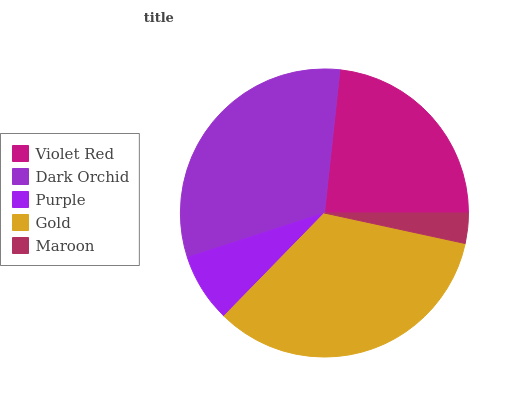Is Maroon the minimum?
Answer yes or no. Yes. Is Gold the maximum?
Answer yes or no. Yes. Is Dark Orchid the minimum?
Answer yes or no. No. Is Dark Orchid the maximum?
Answer yes or no. No. Is Dark Orchid greater than Violet Red?
Answer yes or no. Yes. Is Violet Red less than Dark Orchid?
Answer yes or no. Yes. Is Violet Red greater than Dark Orchid?
Answer yes or no. No. Is Dark Orchid less than Violet Red?
Answer yes or no. No. Is Violet Red the high median?
Answer yes or no. Yes. Is Violet Red the low median?
Answer yes or no. Yes. Is Gold the high median?
Answer yes or no. No. Is Maroon the low median?
Answer yes or no. No. 